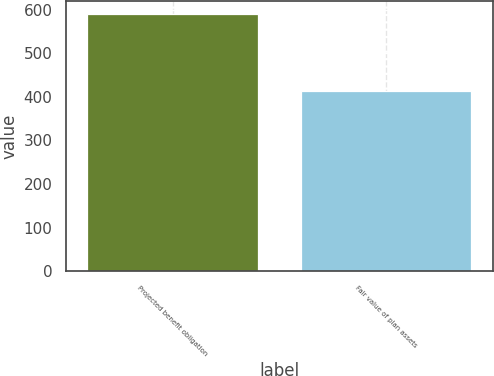Convert chart to OTSL. <chart><loc_0><loc_0><loc_500><loc_500><bar_chart><fcel>Projected benefit obligation<fcel>Fair value of plan assets<nl><fcel>590<fcel>414<nl></chart> 